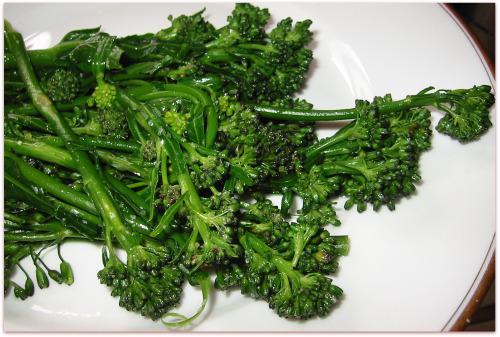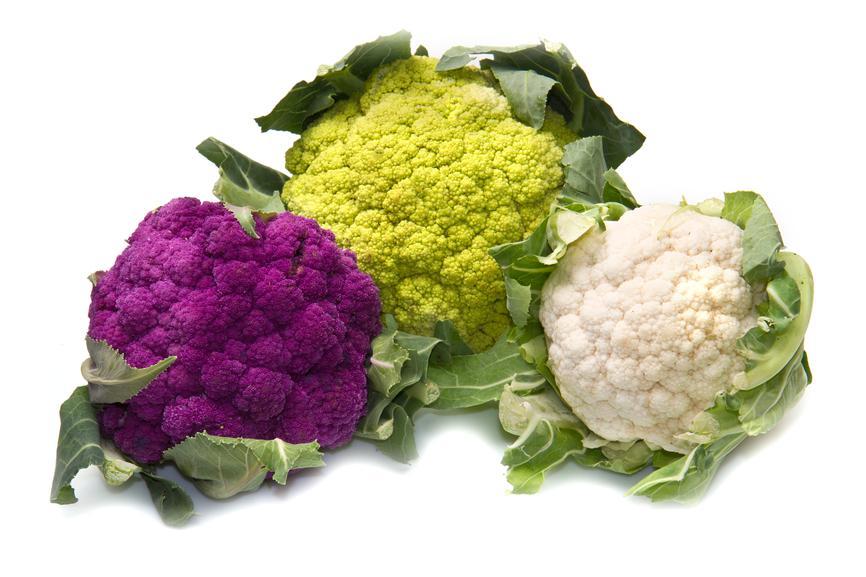The first image is the image on the left, the second image is the image on the right. For the images displayed, is the sentence "One of the vegetables has purple colored sprouts." factually correct? Answer yes or no. Yes. The first image is the image on the left, the second image is the image on the right. Analyze the images presented: Is the assertion "One photo shows vegetables lying on a rough wooden surface." valid? Answer yes or no. No. 